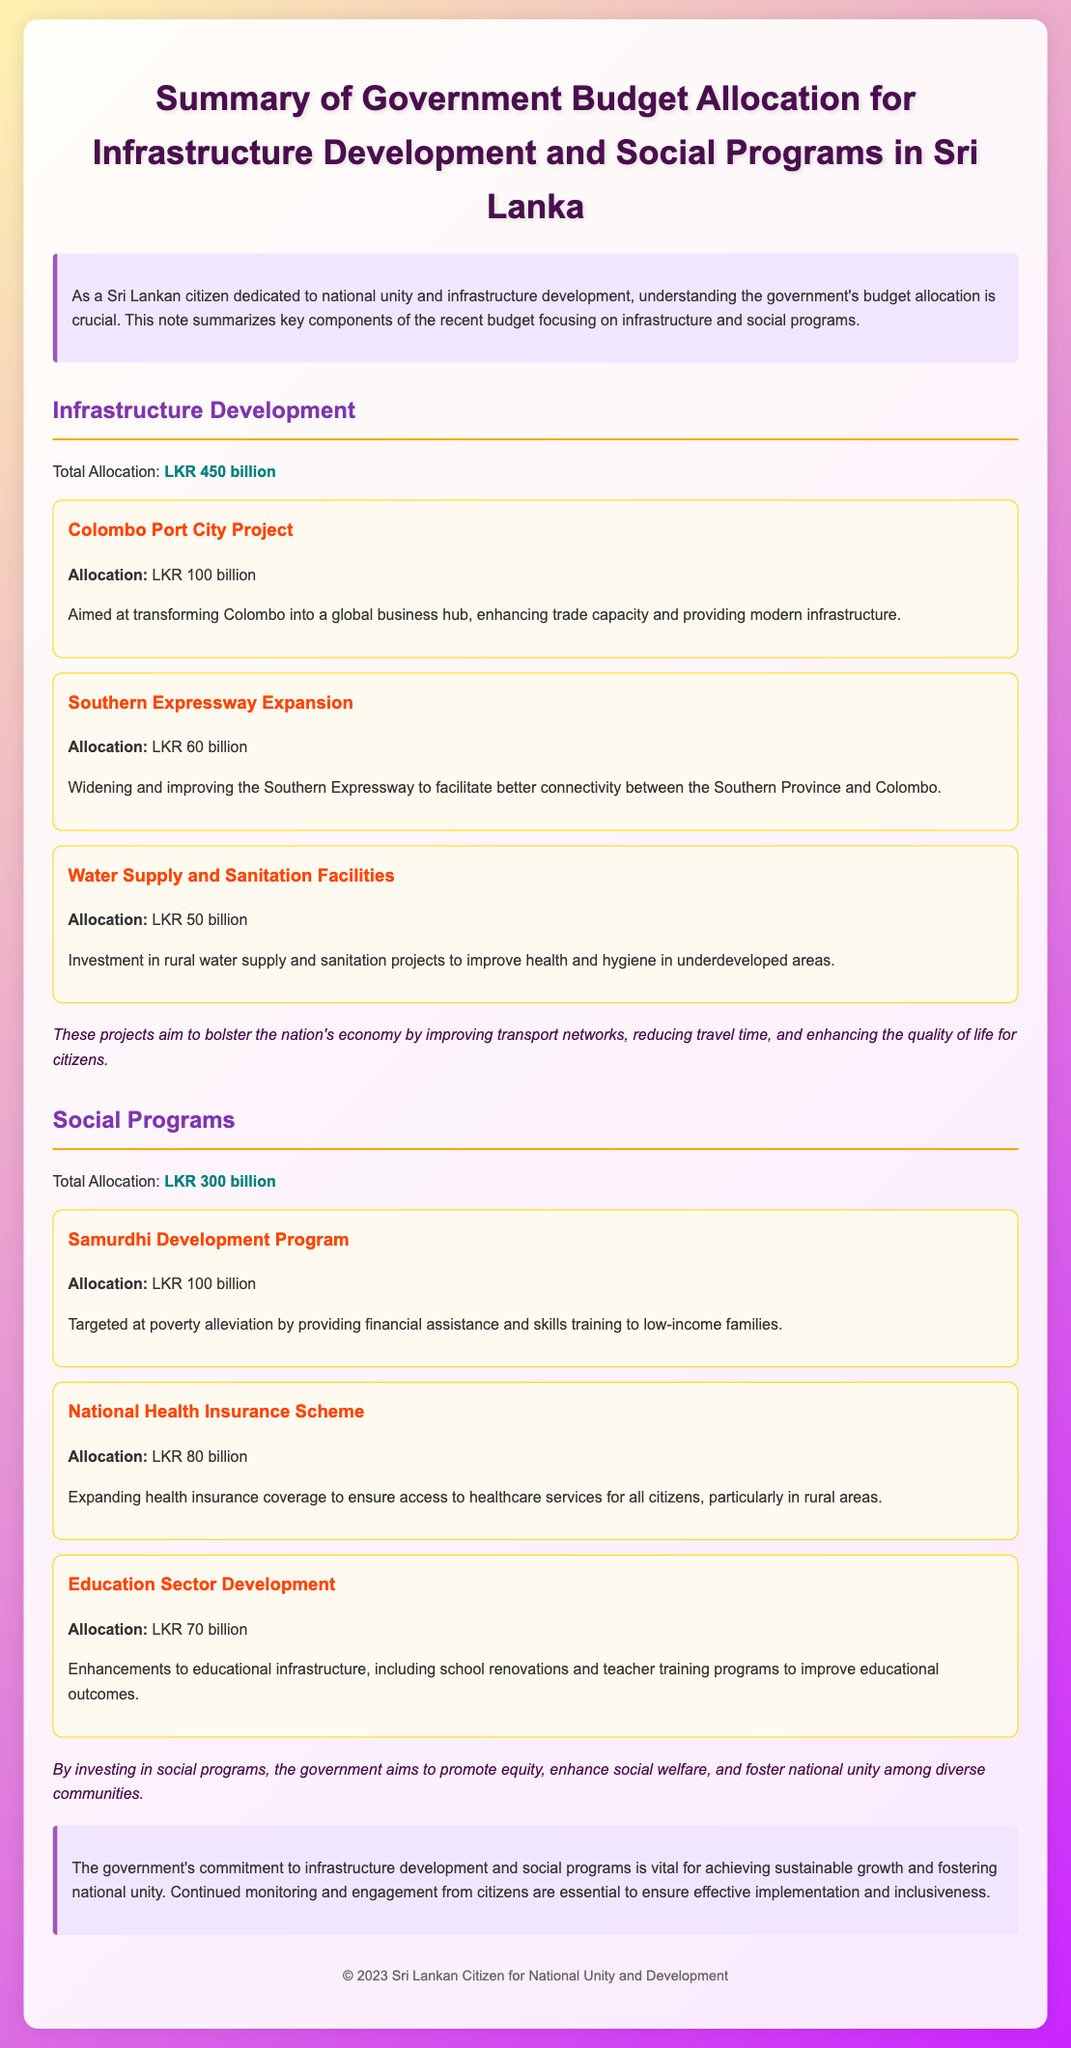What is the total allocation for infrastructure development? The total allocation for infrastructure development is explicitly stated in the document.
Answer: LKR 450 billion What is the allocation for the Colombo Port City Project? The specific allocation for the Colombo Port City Project is mentioned under the infrastructure section.
Answer: LKR 100 billion What is one of the goals of the Samurdhi Development Program? The goals of the Samurdhi Development Program are described in the context of poverty alleviation.
Answer: Poverty alleviation How much is allocated to the National Health Insurance Scheme? The exact amount designated for the National Health Insurance Scheme is provided in the social programs section.
Answer: LKR 80 billion What type of investment is mentioned under Water Supply and Sanitation Facilities? Description provided in the project section highlights the focus of the Water Supply and Sanitation Facilities investment.
Answer: Rural water supply and sanitation How does the government aim to enhance educational outcomes? The enhancement strategies are outlined in the Education Sector Development project description in the document.
Answer: School renovations and teacher training programs What is the total allocation for social programs? The total allocation amount for social programs is specified in the document.
Answer: LKR 300 billion What is the intended outcome of investing in social programs? The impact of investing in social programs is summarized in the document.
Answer: Promote equity and enhance social welfare 